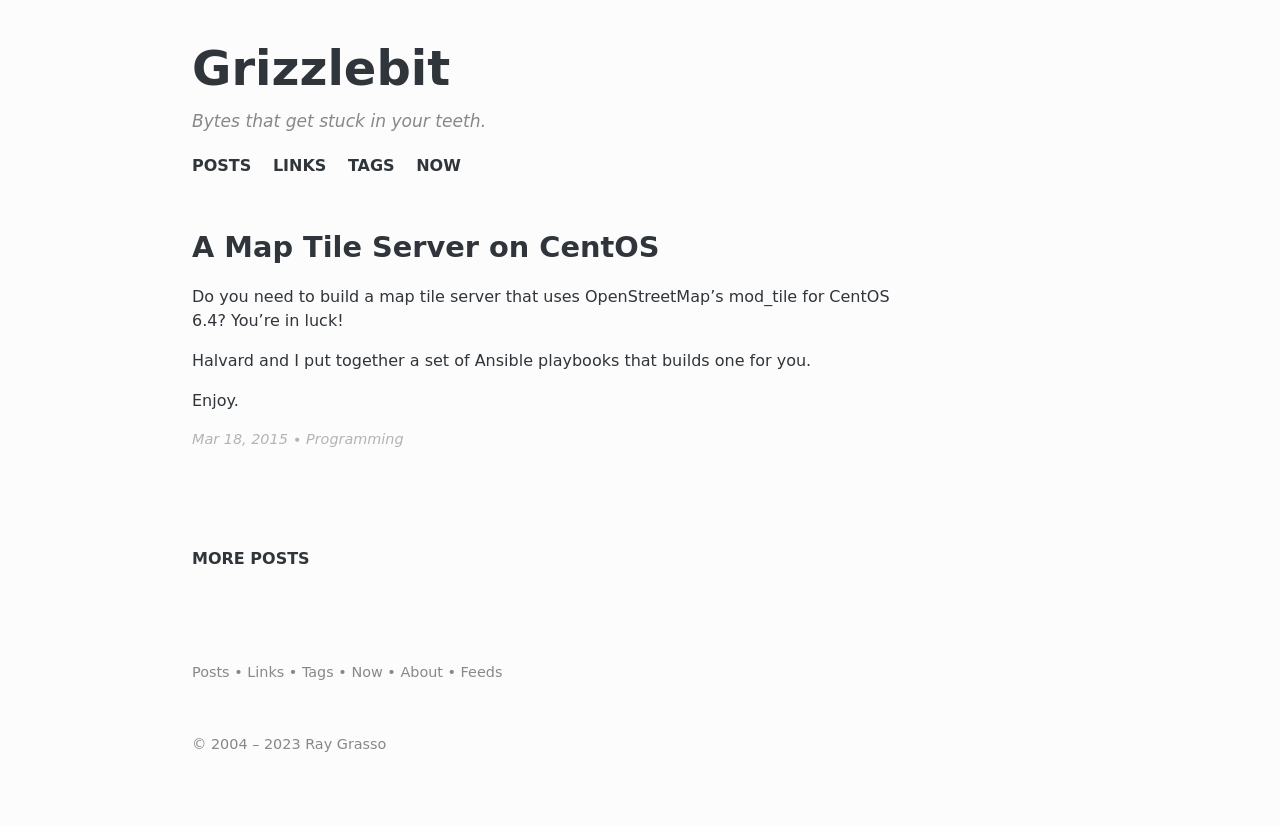What's the procedure for constructing this website from scratch with HTML? To construct a website from scratch with HTML, you would start by creating a basic HTML skeleton with 'doctype', 'html', 'head', and 'body' tags. Within the 'head', add metadata like 'charset', 'viewport', and 'title' tags. The 'body' will contain all visible content, organized using tags like 'header', 'nav', 'main', 'section', 'article', 'footer', etc., along with 'h1' to 'h6' for headings, 'p' for paragraphs, 'a' for links, 'img' for images, and more. Additionally, CSS is used for styling, and JavaScript is added for interactivity. All these elements need to be well-structured and tested across different browsers for compatibility. 